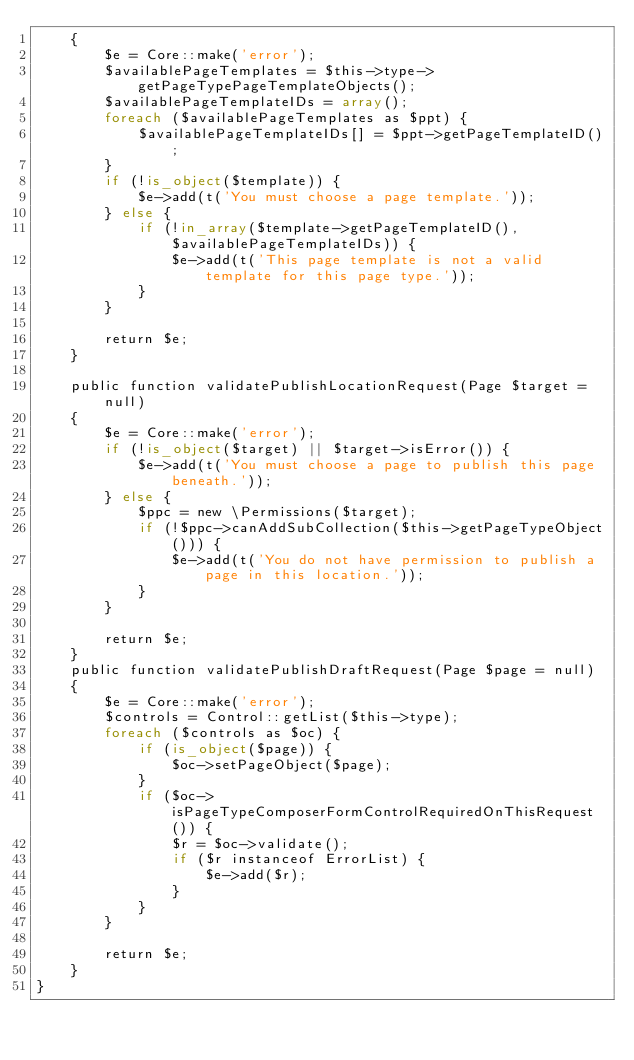<code> <loc_0><loc_0><loc_500><loc_500><_PHP_>    {
        $e = Core::make('error');
        $availablePageTemplates = $this->type->getPageTypePageTemplateObjects();
        $availablePageTemplateIDs = array();
        foreach ($availablePageTemplates as $ppt) {
            $availablePageTemplateIDs[] = $ppt->getPageTemplateID();
        }
        if (!is_object($template)) {
            $e->add(t('You must choose a page template.'));
        } else {
            if (!in_array($template->getPageTemplateID(), $availablePageTemplateIDs)) {
                $e->add(t('This page template is not a valid template for this page type.'));
            }
        }

        return $e;
    }

    public function validatePublishLocationRequest(Page $target = null)
    {
        $e = Core::make('error');
        if (!is_object($target) || $target->isError()) {
            $e->add(t('You must choose a page to publish this page beneath.'));
        } else {
            $ppc = new \Permissions($target);
            if (!$ppc->canAddSubCollection($this->getPageTypeObject())) {
                $e->add(t('You do not have permission to publish a page in this location.'));
            }
        }

        return $e;
    }
    public function validatePublishDraftRequest(Page $page = null)
    {
        $e = Core::make('error');
        $controls = Control::getList($this->type);
        foreach ($controls as $oc) {
            if (is_object($page)) {
                $oc->setPageObject($page);
            }
            if ($oc->isPageTypeComposerFormControlRequiredOnThisRequest()) {
                $r = $oc->validate();
                if ($r instanceof ErrorList) {
                    $e->add($r);
                }
            }
        }

        return $e;
    }
}
</code> 